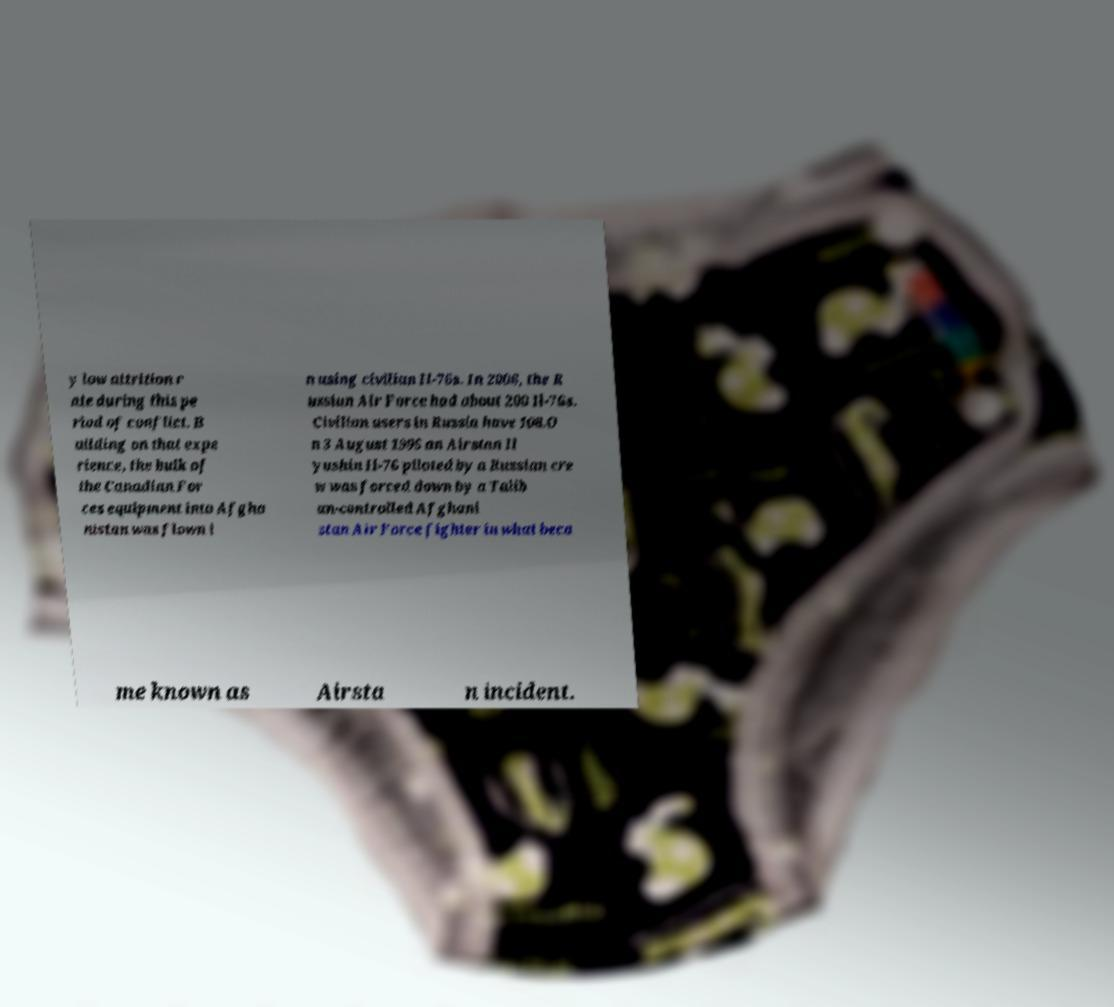Please identify and transcribe the text found in this image. y low attrition r ate during this pe riod of conflict. B uilding on that expe rience, the bulk of the Canadian For ces equipment into Afgha nistan was flown i n using civilian Il-76s. In 2006, the R ussian Air Force had about 200 Il-76s. Civilian users in Russia have 108.O n 3 August 1995 an Airstan Il yushin Il-76 piloted by a Russian cre w was forced down by a Talib an-controlled Afghani stan Air Force fighter in what beca me known as Airsta n incident. 